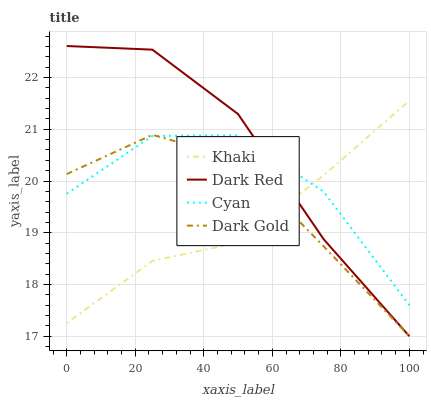Does Khaki have the minimum area under the curve?
Answer yes or no. Yes. Does Dark Red have the maximum area under the curve?
Answer yes or no. Yes. Does Dark Gold have the minimum area under the curve?
Answer yes or no. No. Does Dark Gold have the maximum area under the curve?
Answer yes or no. No. Is Khaki the smoothest?
Answer yes or no. Yes. Is Cyan the roughest?
Answer yes or no. Yes. Is Dark Gold the smoothest?
Answer yes or no. No. Is Dark Gold the roughest?
Answer yes or no. No. Does Khaki have the lowest value?
Answer yes or no. No. Does Dark Red have the highest value?
Answer yes or no. Yes. Does Khaki have the highest value?
Answer yes or no. No. Does Dark Red intersect Cyan?
Answer yes or no. Yes. Is Dark Red less than Cyan?
Answer yes or no. No. Is Dark Red greater than Cyan?
Answer yes or no. No. 